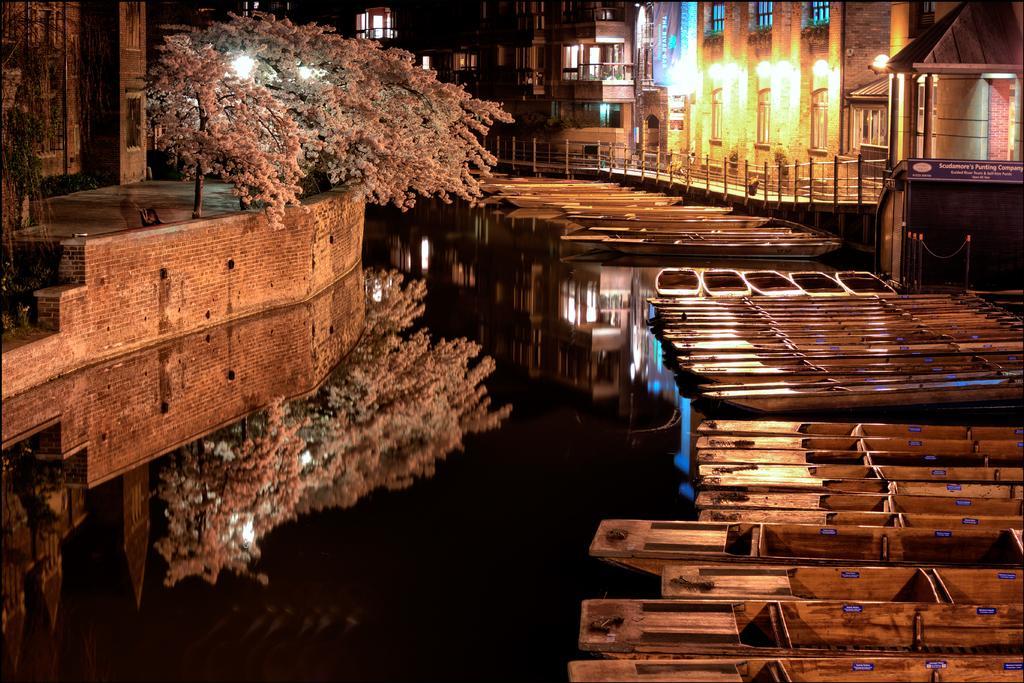Can you describe this image briefly? In this image there are buildings truncated towards the top of the image, there is a buildings truncated towards the right of the image, there is a building truncated towards the left of the image, there are trees, there is a tree truncated towards the left of the image, there is a wall truncated towards the left of the image, there is water truncated towards the bottom of the image, there are boats on the water, there are boats truncated towards the bottom of the image, there are boats truncated towards the right of the image, there is a wall truncated towards the right of the image, there is a board truncated towards the right of the image, there is text on the board. 